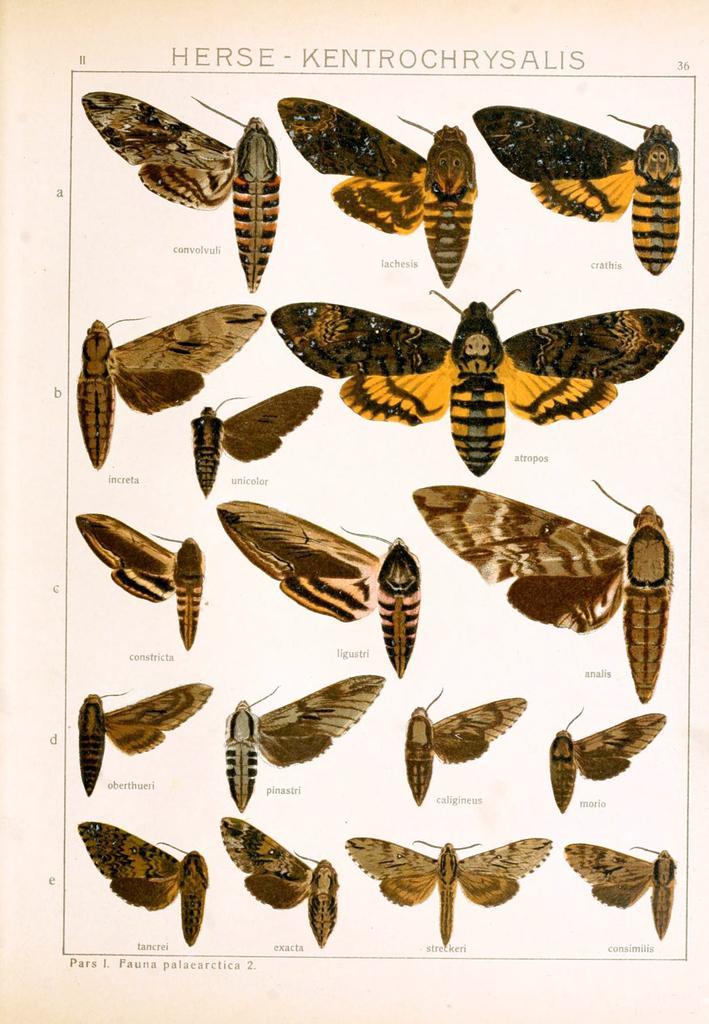Describe this image in one or two sentences. In the image we can see a poster with the pictures of some insects and there is some text on the poster. 